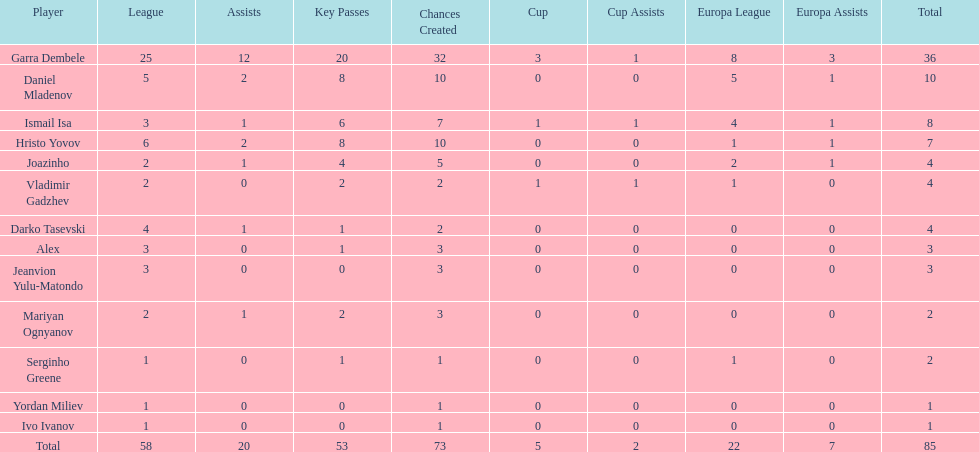Who was the top goalscorer on this team? Garra Dembele. 